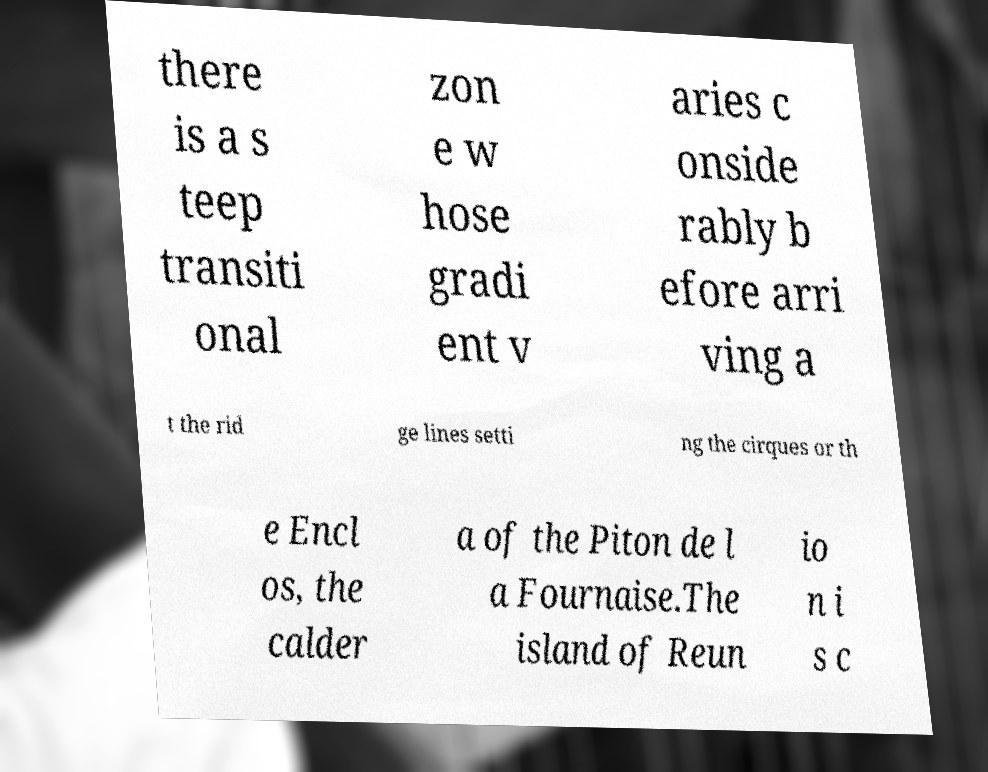What messages or text are displayed in this image? I need them in a readable, typed format. there is a s teep transiti onal zon e w hose gradi ent v aries c onside rably b efore arri ving a t the rid ge lines setti ng the cirques or th e Encl os, the calder a of the Piton de l a Fournaise.The island of Reun io n i s c 